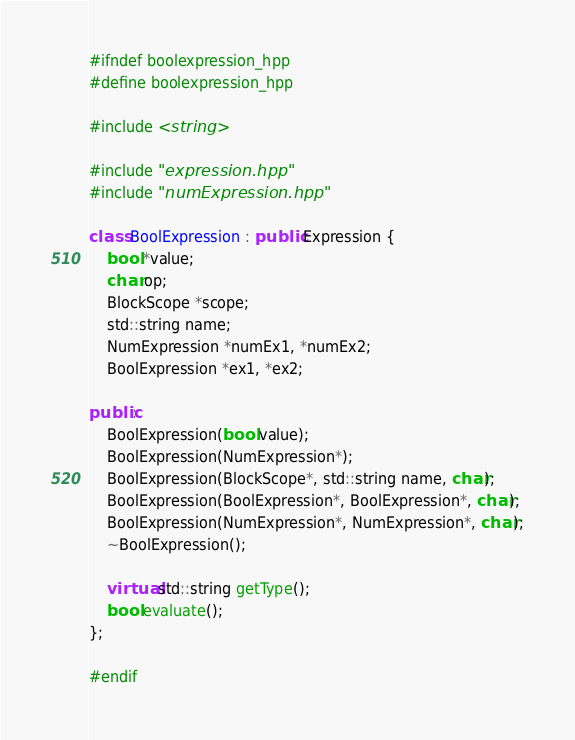<code> <loc_0><loc_0><loc_500><loc_500><_C++_>#ifndef boolexpression_hpp
#define boolexpression_hpp

#include <string>

#include "expression.hpp"
#include "numExpression.hpp"

class BoolExpression : public Expression {
    bool *value;
    char op;
    BlockScope *scope;
    std::string name;
    NumExpression *numEx1, *numEx2;
    BoolExpression *ex1, *ex2;

public:
    BoolExpression(bool value);
    BoolExpression(NumExpression*);
    BoolExpression(BlockScope*, std::string name, char);
    BoolExpression(BoolExpression*, BoolExpression*, char);
    BoolExpression(NumExpression*, NumExpression*, char);
    ~BoolExpression();

    virtual std::string getType();
    bool evaluate();
};

#endif
</code> 